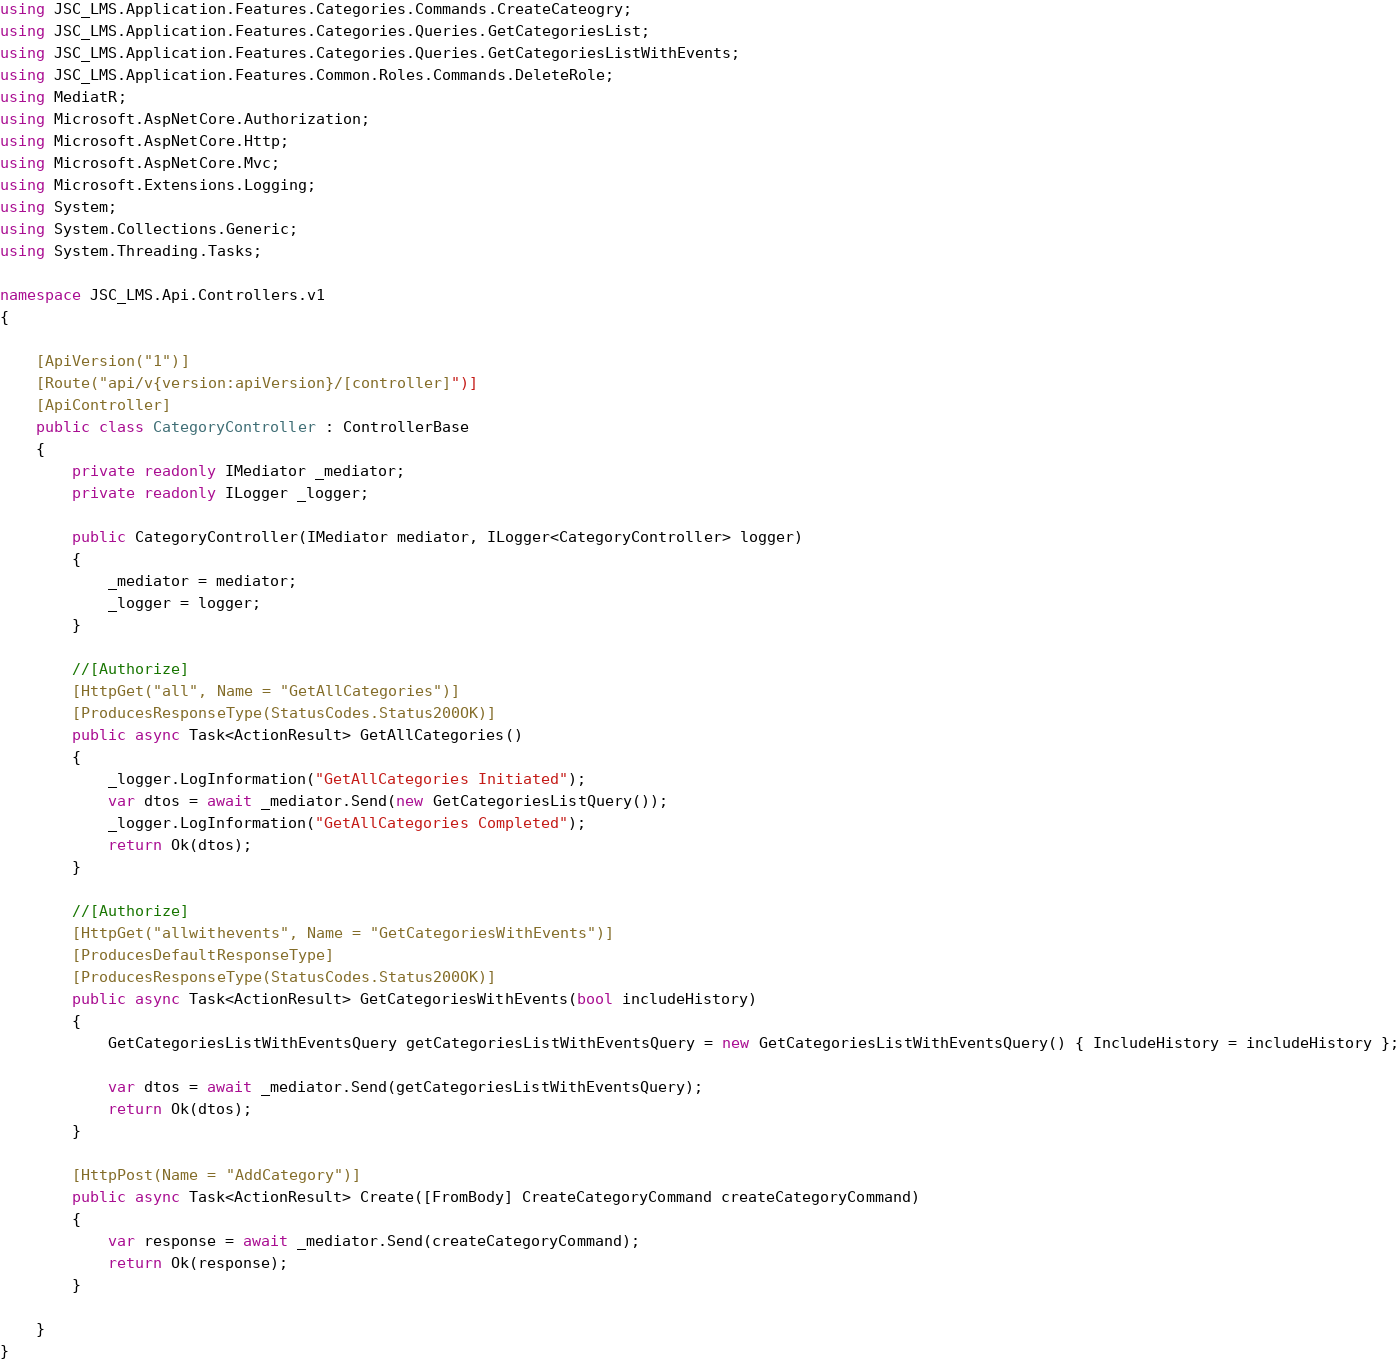Convert code to text. <code><loc_0><loc_0><loc_500><loc_500><_C#_>using JSC_LMS.Application.Features.Categories.Commands.CreateCateogry;
using JSC_LMS.Application.Features.Categories.Queries.GetCategoriesList;
using JSC_LMS.Application.Features.Categories.Queries.GetCategoriesListWithEvents;
using JSC_LMS.Application.Features.Common.Roles.Commands.DeleteRole;
using MediatR;
using Microsoft.AspNetCore.Authorization;
using Microsoft.AspNetCore.Http;
using Microsoft.AspNetCore.Mvc;
using Microsoft.Extensions.Logging;
using System;
using System.Collections.Generic;
using System.Threading.Tasks;

namespace JSC_LMS.Api.Controllers.v1
{

    [ApiVersion("1")]
    [Route("api/v{version:apiVersion}/[controller]")]
    [ApiController]
    public class CategoryController : ControllerBase
    {
        private readonly IMediator _mediator;
        private readonly ILogger _logger;

        public CategoryController(IMediator mediator, ILogger<CategoryController> logger)
        {
            _mediator = mediator;
            _logger = logger;
        }

        //[Authorize]
        [HttpGet("all", Name = "GetAllCategories")]
        [ProducesResponseType(StatusCodes.Status200OK)]
        public async Task<ActionResult> GetAllCategories()
        {
            _logger.LogInformation("GetAllCategories Initiated");
            var dtos = await _mediator.Send(new GetCategoriesListQuery());
            _logger.LogInformation("GetAllCategories Completed");
            return Ok(dtos);
        }

        //[Authorize]
        [HttpGet("allwithevents", Name = "GetCategoriesWithEvents")]
        [ProducesDefaultResponseType]
        [ProducesResponseType(StatusCodes.Status200OK)]
        public async Task<ActionResult> GetCategoriesWithEvents(bool includeHistory)
        {
            GetCategoriesListWithEventsQuery getCategoriesListWithEventsQuery = new GetCategoriesListWithEventsQuery() { IncludeHistory = includeHistory };

            var dtos = await _mediator.Send(getCategoriesListWithEventsQuery);
            return Ok(dtos);
        }

        [HttpPost(Name = "AddCategory")]
        public async Task<ActionResult> Create([FromBody] CreateCategoryCommand createCategoryCommand)
        {
            var response = await _mediator.Send(createCategoryCommand);
            return Ok(response);
        }
        
    }
}
</code> 